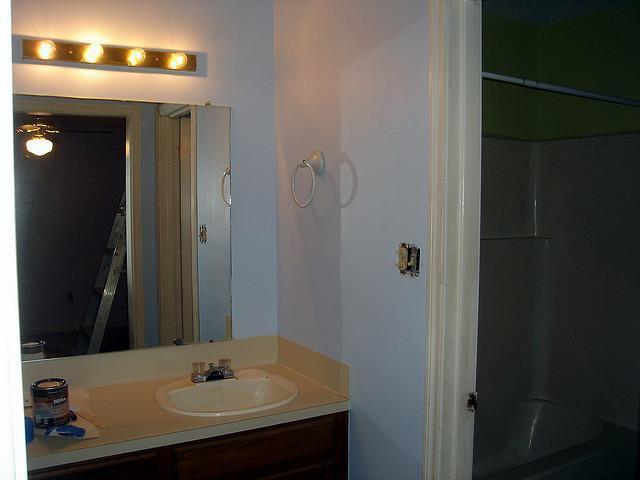How many lights are above the mirror?
Give a very brief answer. 4. How many sinks are in the picture?
Give a very brief answer. 1. How many lights are on?
Give a very brief answer. 5. How many toothbrushes does the boy have?
Give a very brief answer. 0. 